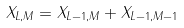<formula> <loc_0><loc_0><loc_500><loc_500>X _ { L , M } = X _ { L - 1 , M } + X _ { L - 1 , M - 1 }</formula> 